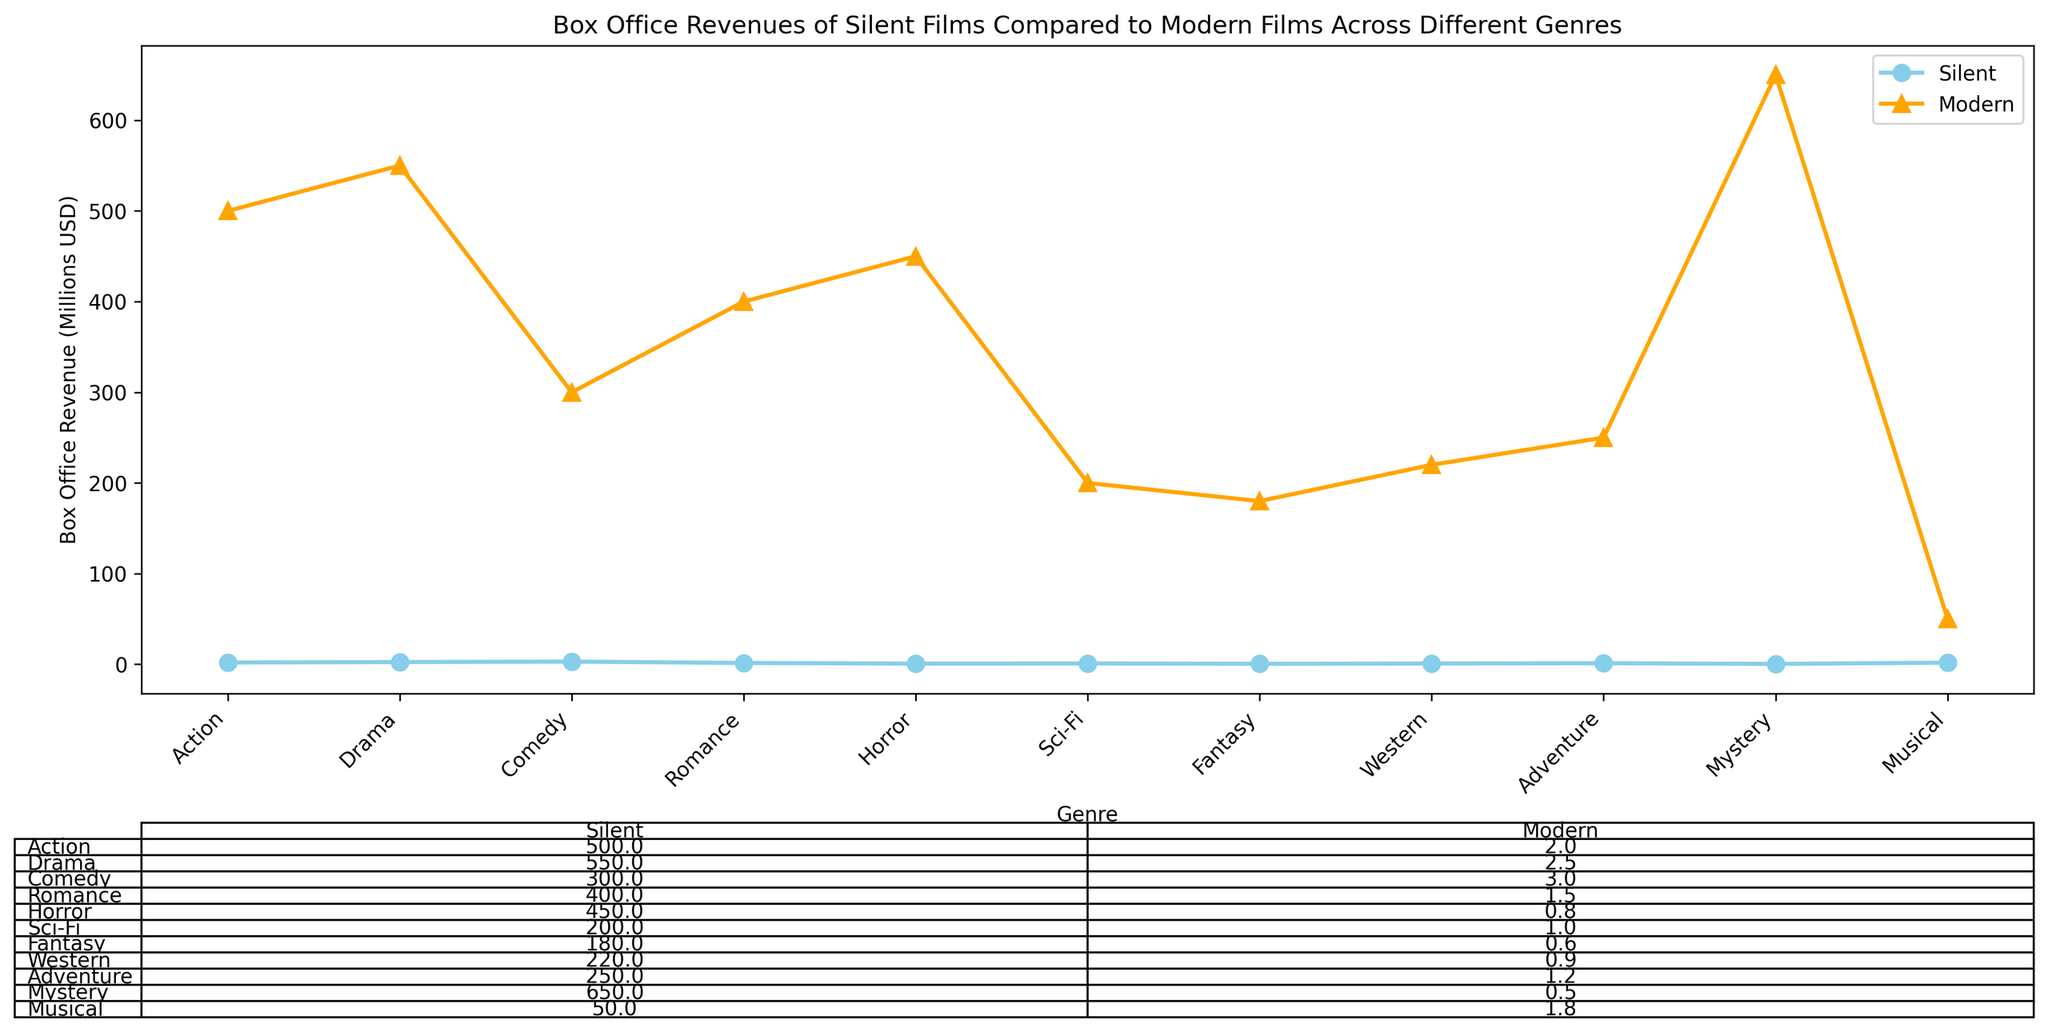Which genre has the highest box office revenue for modern films? The highest box office revenue for modern films can be identified by looking at the highest point in the orange-colored line. The highest point is for the Sci-Fi genre, which is 650 million USD.
Answer: Sci-Fi Which genre has the lowest box office revenue for silent films? The lowest box office revenue for silent films can be found by identifying the lowest point on the sky-blue line. The lowest point is for the Sci-Fi genre, which is 0.5 million USD.
Answer: Sci-Fi How much more revenue do modern adventure films generate compared to silent adventure films? To find the difference, subtract the revenue for silent adventure films from the revenue for modern adventure films. Modern adventure films generate 550 million USD, and silent adventure films generate 2.5 million USD. So, the difference is 550 - 2.5 = 547.5 million USD.
Answer: 547.5 million USD What is the total box office revenue for modern films across all genres? Sum up the box office revenues for modern films across all genres: 500 (Action) + 400 (Drama) + 300 (Comedy) + 250 (Romance) + 200 (Horror) + 650 (Sci-Fi) + 450 (Fantasy) + 50 (Western) + 550 (Adventure) + 220 (Mystery) + 180 (Musical) = 3750 million USD.
Answer: 3750 million USD How does the box office revenue for modern romantic films compare to the box office revenue for modern musical films? Compare the revenue for modern romantic films (250 million USD) and modern musical films (180 million USD). 250 million USD is greater than 180 million USD.
Answer: Modern romantic films have higher revenue What is the average box office revenue for silent films? To find the average, sum up the box office revenue for silent films and divide by the number of genres. The total revenue for silent films is: 2 + 1.5 + 3 + 1.2 + 1 + 0.5 + 0.8 + 1.8 + 2.5 + 0.9 + 0.6 = 15.8 million USD. There are 11 genres, so the average is 15.8 / 11 = 1.436 million USD.
Answer: 1.436 million USD Which silent film genre has a higher box office revenue compared to its modern counterpart? Identify any genre where the sky-blue point (silent film) is above the orange point (modern film). Only Western has a higher box office revenue for silent films (1.8 million USD) compared to modern films (50 million USD).
Answer: Western 